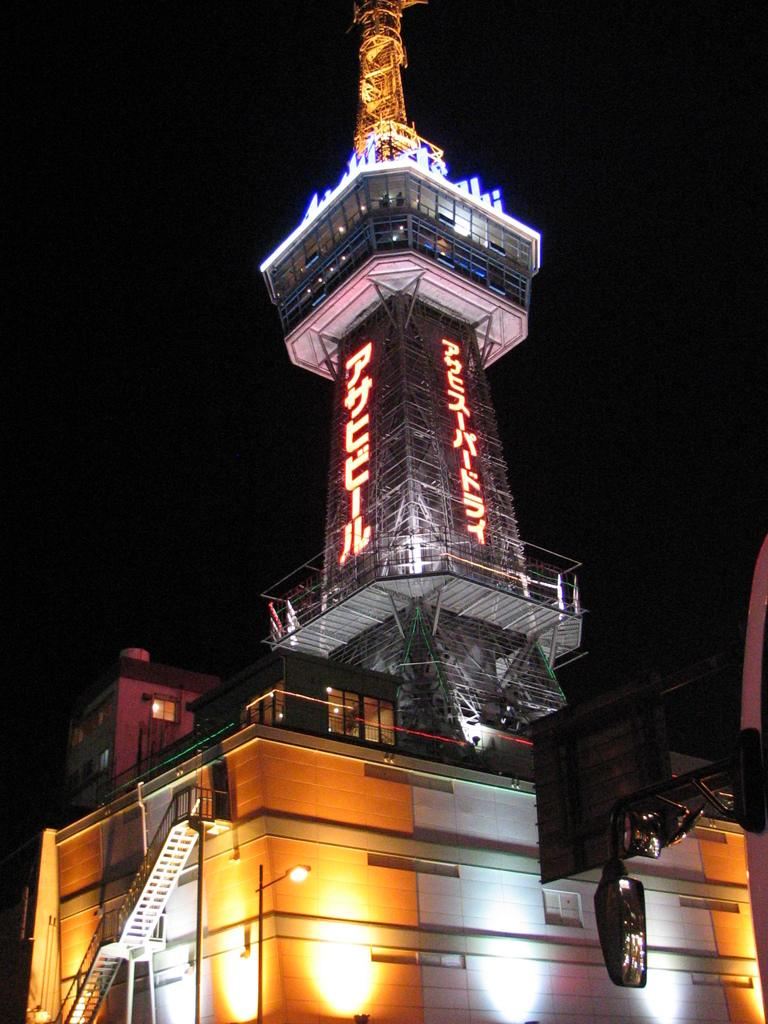What type of structure is present in the image? There is a building in the image. What additional feature can be seen on the building? There is a tower in the image. What can be seen illuminated in the image? There are lights visible in the image. How would you describe the overall lighting in the image? The background of the image is dark. What type of machine is being used to control the speed of the vehicle in the image? There is no vehicle or machine present in the image; it features a building and a tower. How does the yoke help in steering the vehicle in the image? There is no vehicle or yoke present in the image; it features a building and a tower. 